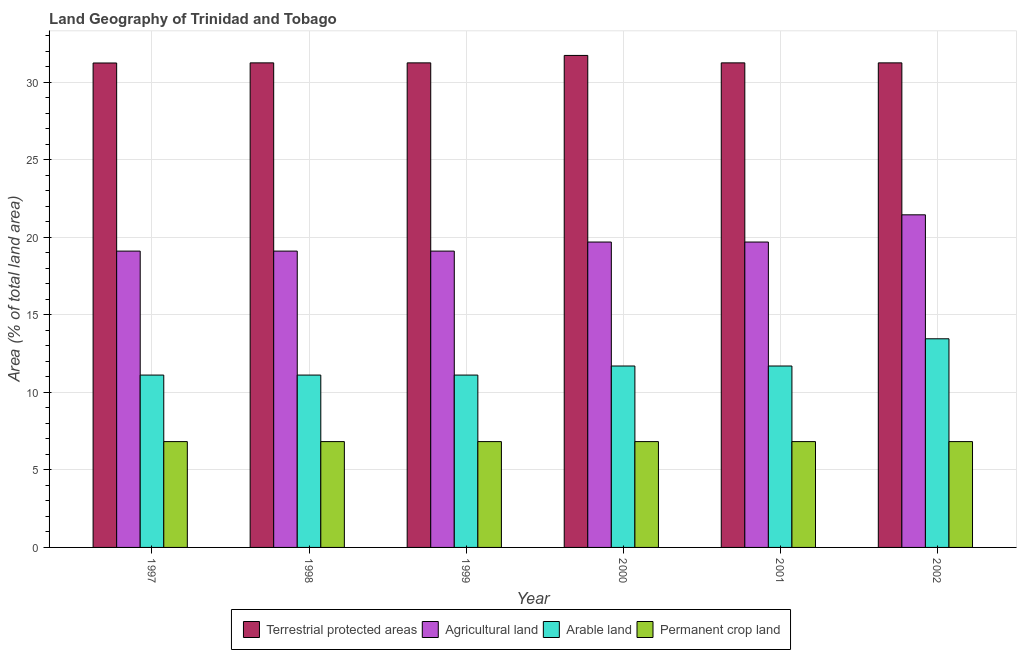How many different coloured bars are there?
Provide a succinct answer. 4. Are the number of bars per tick equal to the number of legend labels?
Your answer should be very brief. Yes. How many bars are there on the 3rd tick from the left?
Your answer should be very brief. 4. How many bars are there on the 5th tick from the right?
Your answer should be compact. 4. What is the percentage of area under permanent crop land in 1997?
Give a very brief answer. 6.82. Across all years, what is the maximum percentage of area under arable land?
Keep it short and to the point. 13.45. Across all years, what is the minimum percentage of area under agricultural land?
Provide a succinct answer. 19.1. In which year was the percentage of area under agricultural land maximum?
Offer a very short reply. 2002. In which year was the percentage of area under arable land minimum?
Give a very brief answer. 1997. What is the total percentage of area under agricultural land in the graph?
Give a very brief answer. 118.13. What is the difference between the percentage of area under arable land in 1998 and that in 2000?
Your answer should be compact. -0.58. What is the difference between the percentage of area under agricultural land in 1997 and the percentage of area under permanent crop land in 1998?
Make the answer very short. 0. What is the average percentage of area under agricultural land per year?
Provide a short and direct response. 19.69. In how many years, is the percentage of area under permanent crop land greater than 9 %?
Give a very brief answer. 0. What is the ratio of the percentage of land under terrestrial protection in 2000 to that in 2002?
Provide a succinct answer. 1.02. Is the percentage of area under permanent crop land in 1999 less than that in 2002?
Your answer should be compact. No. What is the difference between the highest and the second highest percentage of area under permanent crop land?
Provide a short and direct response. 0. What is the difference between the highest and the lowest percentage of land under terrestrial protection?
Give a very brief answer. 0.49. In how many years, is the percentage of area under arable land greater than the average percentage of area under arable land taken over all years?
Ensure brevity in your answer.  1. Is the sum of the percentage of area under permanent crop land in 1997 and 2000 greater than the maximum percentage of area under agricultural land across all years?
Your answer should be very brief. Yes. What does the 3rd bar from the left in 1999 represents?
Your answer should be very brief. Arable land. What does the 2nd bar from the right in 2000 represents?
Keep it short and to the point. Arable land. Is it the case that in every year, the sum of the percentage of land under terrestrial protection and percentage of area under agricultural land is greater than the percentage of area under arable land?
Give a very brief answer. Yes. How many years are there in the graph?
Your response must be concise. 6. What is the difference between two consecutive major ticks on the Y-axis?
Your response must be concise. 5. Are the values on the major ticks of Y-axis written in scientific E-notation?
Your answer should be compact. No. Does the graph contain any zero values?
Make the answer very short. No. Does the graph contain grids?
Your answer should be very brief. Yes. How many legend labels are there?
Give a very brief answer. 4. What is the title of the graph?
Provide a short and direct response. Land Geography of Trinidad and Tobago. What is the label or title of the Y-axis?
Your answer should be very brief. Area (% of total land area). What is the Area (% of total land area) in Terrestrial protected areas in 1997?
Offer a terse response. 31.23. What is the Area (% of total land area) of Agricultural land in 1997?
Ensure brevity in your answer.  19.1. What is the Area (% of total land area) of Arable land in 1997?
Provide a succinct answer. 11.11. What is the Area (% of total land area) of Permanent crop land in 1997?
Keep it short and to the point. 6.82. What is the Area (% of total land area) in Terrestrial protected areas in 1998?
Ensure brevity in your answer.  31.24. What is the Area (% of total land area) in Agricultural land in 1998?
Keep it short and to the point. 19.1. What is the Area (% of total land area) in Arable land in 1998?
Offer a terse response. 11.11. What is the Area (% of total land area) of Permanent crop land in 1998?
Your answer should be compact. 6.82. What is the Area (% of total land area) of Terrestrial protected areas in 1999?
Make the answer very short. 31.24. What is the Area (% of total land area) in Agricultural land in 1999?
Ensure brevity in your answer.  19.1. What is the Area (% of total land area) in Arable land in 1999?
Provide a succinct answer. 11.11. What is the Area (% of total land area) in Permanent crop land in 1999?
Your response must be concise. 6.82. What is the Area (% of total land area) in Terrestrial protected areas in 2000?
Provide a succinct answer. 31.72. What is the Area (% of total land area) of Agricultural land in 2000?
Offer a terse response. 19.69. What is the Area (% of total land area) in Arable land in 2000?
Your answer should be very brief. 11.7. What is the Area (% of total land area) of Permanent crop land in 2000?
Keep it short and to the point. 6.82. What is the Area (% of total land area) of Terrestrial protected areas in 2001?
Your answer should be compact. 31.24. What is the Area (% of total land area) in Agricultural land in 2001?
Your answer should be compact. 19.69. What is the Area (% of total land area) of Arable land in 2001?
Your answer should be very brief. 11.7. What is the Area (% of total land area) of Permanent crop land in 2001?
Offer a terse response. 6.82. What is the Area (% of total land area) in Terrestrial protected areas in 2002?
Your response must be concise. 31.24. What is the Area (% of total land area) in Agricultural land in 2002?
Offer a very short reply. 21.44. What is the Area (% of total land area) of Arable land in 2002?
Offer a very short reply. 13.45. What is the Area (% of total land area) of Permanent crop land in 2002?
Your answer should be compact. 6.82. Across all years, what is the maximum Area (% of total land area) of Terrestrial protected areas?
Keep it short and to the point. 31.72. Across all years, what is the maximum Area (% of total land area) of Agricultural land?
Provide a succinct answer. 21.44. Across all years, what is the maximum Area (% of total land area) of Arable land?
Provide a short and direct response. 13.45. Across all years, what is the maximum Area (% of total land area) of Permanent crop land?
Your response must be concise. 6.82. Across all years, what is the minimum Area (% of total land area) of Terrestrial protected areas?
Keep it short and to the point. 31.23. Across all years, what is the minimum Area (% of total land area) in Agricultural land?
Provide a short and direct response. 19.1. Across all years, what is the minimum Area (% of total land area) of Arable land?
Keep it short and to the point. 11.11. Across all years, what is the minimum Area (% of total land area) in Permanent crop land?
Keep it short and to the point. 6.82. What is the total Area (% of total land area) of Terrestrial protected areas in the graph?
Keep it short and to the point. 187.9. What is the total Area (% of total land area) of Agricultural land in the graph?
Keep it short and to the point. 118.13. What is the total Area (% of total land area) in Arable land in the graph?
Your answer should be very brief. 70.18. What is the total Area (% of total land area) of Permanent crop land in the graph?
Your answer should be very brief. 40.94. What is the difference between the Area (% of total land area) in Terrestrial protected areas in 1997 and that in 1998?
Keep it short and to the point. -0.01. What is the difference between the Area (% of total land area) in Terrestrial protected areas in 1997 and that in 1999?
Provide a short and direct response. -0.01. What is the difference between the Area (% of total land area) in Agricultural land in 1997 and that in 1999?
Provide a short and direct response. 0. What is the difference between the Area (% of total land area) of Arable land in 1997 and that in 1999?
Offer a terse response. 0. What is the difference between the Area (% of total land area) of Terrestrial protected areas in 1997 and that in 2000?
Provide a short and direct response. -0.49. What is the difference between the Area (% of total land area) in Agricultural land in 1997 and that in 2000?
Your answer should be very brief. -0.58. What is the difference between the Area (% of total land area) of Arable land in 1997 and that in 2000?
Give a very brief answer. -0.58. What is the difference between the Area (% of total land area) in Terrestrial protected areas in 1997 and that in 2001?
Provide a short and direct response. -0.01. What is the difference between the Area (% of total land area) in Agricultural land in 1997 and that in 2001?
Make the answer very short. -0.58. What is the difference between the Area (% of total land area) in Arable land in 1997 and that in 2001?
Offer a very short reply. -0.58. What is the difference between the Area (% of total land area) in Permanent crop land in 1997 and that in 2001?
Keep it short and to the point. 0. What is the difference between the Area (% of total land area) in Terrestrial protected areas in 1997 and that in 2002?
Ensure brevity in your answer.  -0.01. What is the difference between the Area (% of total land area) of Agricultural land in 1997 and that in 2002?
Make the answer very short. -2.34. What is the difference between the Area (% of total land area) in Arable land in 1997 and that in 2002?
Provide a short and direct response. -2.34. What is the difference between the Area (% of total land area) of Permanent crop land in 1997 and that in 2002?
Your answer should be very brief. 0. What is the difference between the Area (% of total land area) in Terrestrial protected areas in 1998 and that in 1999?
Provide a succinct answer. 0. What is the difference between the Area (% of total land area) in Arable land in 1998 and that in 1999?
Provide a succinct answer. 0. What is the difference between the Area (% of total land area) of Terrestrial protected areas in 1998 and that in 2000?
Your response must be concise. -0.48. What is the difference between the Area (% of total land area) in Agricultural land in 1998 and that in 2000?
Provide a short and direct response. -0.58. What is the difference between the Area (% of total land area) of Arable land in 1998 and that in 2000?
Your answer should be compact. -0.58. What is the difference between the Area (% of total land area) of Terrestrial protected areas in 1998 and that in 2001?
Provide a succinct answer. 0. What is the difference between the Area (% of total land area) in Agricultural land in 1998 and that in 2001?
Provide a succinct answer. -0.58. What is the difference between the Area (% of total land area) of Arable land in 1998 and that in 2001?
Provide a short and direct response. -0.58. What is the difference between the Area (% of total land area) in Permanent crop land in 1998 and that in 2001?
Provide a short and direct response. 0. What is the difference between the Area (% of total land area) of Terrestrial protected areas in 1998 and that in 2002?
Make the answer very short. 0. What is the difference between the Area (% of total land area) in Agricultural land in 1998 and that in 2002?
Keep it short and to the point. -2.34. What is the difference between the Area (% of total land area) in Arable land in 1998 and that in 2002?
Provide a short and direct response. -2.34. What is the difference between the Area (% of total land area) of Terrestrial protected areas in 1999 and that in 2000?
Your answer should be very brief. -0.48. What is the difference between the Area (% of total land area) of Agricultural land in 1999 and that in 2000?
Give a very brief answer. -0.58. What is the difference between the Area (% of total land area) in Arable land in 1999 and that in 2000?
Make the answer very short. -0.58. What is the difference between the Area (% of total land area) in Terrestrial protected areas in 1999 and that in 2001?
Your response must be concise. 0. What is the difference between the Area (% of total land area) in Agricultural land in 1999 and that in 2001?
Offer a very short reply. -0.58. What is the difference between the Area (% of total land area) of Arable land in 1999 and that in 2001?
Provide a succinct answer. -0.58. What is the difference between the Area (% of total land area) in Permanent crop land in 1999 and that in 2001?
Offer a very short reply. 0. What is the difference between the Area (% of total land area) of Terrestrial protected areas in 1999 and that in 2002?
Offer a terse response. 0. What is the difference between the Area (% of total land area) in Agricultural land in 1999 and that in 2002?
Keep it short and to the point. -2.34. What is the difference between the Area (% of total land area) in Arable land in 1999 and that in 2002?
Your response must be concise. -2.34. What is the difference between the Area (% of total land area) in Permanent crop land in 1999 and that in 2002?
Keep it short and to the point. 0. What is the difference between the Area (% of total land area) in Terrestrial protected areas in 2000 and that in 2001?
Provide a short and direct response. 0.48. What is the difference between the Area (% of total land area) in Agricultural land in 2000 and that in 2001?
Keep it short and to the point. 0. What is the difference between the Area (% of total land area) of Permanent crop land in 2000 and that in 2001?
Offer a very short reply. 0. What is the difference between the Area (% of total land area) of Terrestrial protected areas in 2000 and that in 2002?
Your answer should be very brief. 0.48. What is the difference between the Area (% of total land area) of Agricultural land in 2000 and that in 2002?
Give a very brief answer. -1.75. What is the difference between the Area (% of total land area) in Arable land in 2000 and that in 2002?
Give a very brief answer. -1.75. What is the difference between the Area (% of total land area) in Agricultural land in 2001 and that in 2002?
Provide a short and direct response. -1.75. What is the difference between the Area (% of total land area) in Arable land in 2001 and that in 2002?
Offer a terse response. -1.75. What is the difference between the Area (% of total land area) in Terrestrial protected areas in 1997 and the Area (% of total land area) in Agricultural land in 1998?
Your answer should be very brief. 12.13. What is the difference between the Area (% of total land area) in Terrestrial protected areas in 1997 and the Area (% of total land area) in Arable land in 1998?
Your answer should be compact. 20.12. What is the difference between the Area (% of total land area) in Terrestrial protected areas in 1997 and the Area (% of total land area) in Permanent crop land in 1998?
Your answer should be very brief. 24.41. What is the difference between the Area (% of total land area) of Agricultural land in 1997 and the Area (% of total land area) of Arable land in 1998?
Offer a terse response. 7.99. What is the difference between the Area (% of total land area) in Agricultural land in 1997 and the Area (% of total land area) in Permanent crop land in 1998?
Provide a succinct answer. 12.28. What is the difference between the Area (% of total land area) in Arable land in 1997 and the Area (% of total land area) in Permanent crop land in 1998?
Your answer should be very brief. 4.29. What is the difference between the Area (% of total land area) in Terrestrial protected areas in 1997 and the Area (% of total land area) in Agricultural land in 1999?
Keep it short and to the point. 12.13. What is the difference between the Area (% of total land area) in Terrestrial protected areas in 1997 and the Area (% of total land area) in Arable land in 1999?
Make the answer very short. 20.12. What is the difference between the Area (% of total land area) of Terrestrial protected areas in 1997 and the Area (% of total land area) of Permanent crop land in 1999?
Your answer should be very brief. 24.41. What is the difference between the Area (% of total land area) in Agricultural land in 1997 and the Area (% of total land area) in Arable land in 1999?
Offer a very short reply. 7.99. What is the difference between the Area (% of total land area) in Agricultural land in 1997 and the Area (% of total land area) in Permanent crop land in 1999?
Give a very brief answer. 12.28. What is the difference between the Area (% of total land area) of Arable land in 1997 and the Area (% of total land area) of Permanent crop land in 1999?
Your response must be concise. 4.29. What is the difference between the Area (% of total land area) in Terrestrial protected areas in 1997 and the Area (% of total land area) in Agricultural land in 2000?
Keep it short and to the point. 11.54. What is the difference between the Area (% of total land area) in Terrestrial protected areas in 1997 and the Area (% of total land area) in Arable land in 2000?
Offer a very short reply. 19.53. What is the difference between the Area (% of total land area) of Terrestrial protected areas in 1997 and the Area (% of total land area) of Permanent crop land in 2000?
Your answer should be very brief. 24.41. What is the difference between the Area (% of total land area) in Agricultural land in 1997 and the Area (% of total land area) in Arable land in 2000?
Make the answer very short. 7.41. What is the difference between the Area (% of total land area) in Agricultural land in 1997 and the Area (% of total land area) in Permanent crop land in 2000?
Ensure brevity in your answer.  12.28. What is the difference between the Area (% of total land area) in Arable land in 1997 and the Area (% of total land area) in Permanent crop land in 2000?
Offer a very short reply. 4.29. What is the difference between the Area (% of total land area) in Terrestrial protected areas in 1997 and the Area (% of total land area) in Agricultural land in 2001?
Provide a short and direct response. 11.54. What is the difference between the Area (% of total land area) in Terrestrial protected areas in 1997 and the Area (% of total land area) in Arable land in 2001?
Offer a very short reply. 19.53. What is the difference between the Area (% of total land area) in Terrestrial protected areas in 1997 and the Area (% of total land area) in Permanent crop land in 2001?
Provide a succinct answer. 24.41. What is the difference between the Area (% of total land area) in Agricultural land in 1997 and the Area (% of total land area) in Arable land in 2001?
Provide a short and direct response. 7.41. What is the difference between the Area (% of total land area) in Agricultural land in 1997 and the Area (% of total land area) in Permanent crop land in 2001?
Offer a terse response. 12.28. What is the difference between the Area (% of total land area) of Arable land in 1997 and the Area (% of total land area) of Permanent crop land in 2001?
Your answer should be compact. 4.29. What is the difference between the Area (% of total land area) of Terrestrial protected areas in 1997 and the Area (% of total land area) of Agricultural land in 2002?
Make the answer very short. 9.79. What is the difference between the Area (% of total land area) of Terrestrial protected areas in 1997 and the Area (% of total land area) of Arable land in 2002?
Provide a short and direct response. 17.78. What is the difference between the Area (% of total land area) in Terrestrial protected areas in 1997 and the Area (% of total land area) in Permanent crop land in 2002?
Your answer should be very brief. 24.41. What is the difference between the Area (% of total land area) in Agricultural land in 1997 and the Area (% of total land area) in Arable land in 2002?
Provide a succinct answer. 5.65. What is the difference between the Area (% of total land area) of Agricultural land in 1997 and the Area (% of total land area) of Permanent crop land in 2002?
Offer a terse response. 12.28. What is the difference between the Area (% of total land area) of Arable land in 1997 and the Area (% of total land area) of Permanent crop land in 2002?
Provide a succinct answer. 4.29. What is the difference between the Area (% of total land area) of Terrestrial protected areas in 1998 and the Area (% of total land area) of Agricultural land in 1999?
Your answer should be very brief. 12.13. What is the difference between the Area (% of total land area) in Terrestrial protected areas in 1998 and the Area (% of total land area) in Arable land in 1999?
Ensure brevity in your answer.  20.13. What is the difference between the Area (% of total land area) in Terrestrial protected areas in 1998 and the Area (% of total land area) in Permanent crop land in 1999?
Your answer should be compact. 24.42. What is the difference between the Area (% of total land area) in Agricultural land in 1998 and the Area (% of total land area) in Arable land in 1999?
Keep it short and to the point. 7.99. What is the difference between the Area (% of total land area) in Agricultural land in 1998 and the Area (% of total land area) in Permanent crop land in 1999?
Your answer should be very brief. 12.28. What is the difference between the Area (% of total land area) in Arable land in 1998 and the Area (% of total land area) in Permanent crop land in 1999?
Provide a succinct answer. 4.29. What is the difference between the Area (% of total land area) of Terrestrial protected areas in 1998 and the Area (% of total land area) of Agricultural land in 2000?
Your response must be concise. 11.55. What is the difference between the Area (% of total land area) of Terrestrial protected areas in 1998 and the Area (% of total land area) of Arable land in 2000?
Provide a short and direct response. 19.54. What is the difference between the Area (% of total land area) of Terrestrial protected areas in 1998 and the Area (% of total land area) of Permanent crop land in 2000?
Make the answer very short. 24.42. What is the difference between the Area (% of total land area) in Agricultural land in 1998 and the Area (% of total land area) in Arable land in 2000?
Offer a very short reply. 7.41. What is the difference between the Area (% of total land area) in Agricultural land in 1998 and the Area (% of total land area) in Permanent crop land in 2000?
Offer a very short reply. 12.28. What is the difference between the Area (% of total land area) in Arable land in 1998 and the Area (% of total land area) in Permanent crop land in 2000?
Offer a very short reply. 4.29. What is the difference between the Area (% of total land area) of Terrestrial protected areas in 1998 and the Area (% of total land area) of Agricultural land in 2001?
Provide a short and direct response. 11.55. What is the difference between the Area (% of total land area) of Terrestrial protected areas in 1998 and the Area (% of total land area) of Arable land in 2001?
Provide a succinct answer. 19.54. What is the difference between the Area (% of total land area) of Terrestrial protected areas in 1998 and the Area (% of total land area) of Permanent crop land in 2001?
Your answer should be very brief. 24.42. What is the difference between the Area (% of total land area) in Agricultural land in 1998 and the Area (% of total land area) in Arable land in 2001?
Your answer should be compact. 7.41. What is the difference between the Area (% of total land area) in Agricultural land in 1998 and the Area (% of total land area) in Permanent crop land in 2001?
Give a very brief answer. 12.28. What is the difference between the Area (% of total land area) of Arable land in 1998 and the Area (% of total land area) of Permanent crop land in 2001?
Offer a terse response. 4.29. What is the difference between the Area (% of total land area) in Terrestrial protected areas in 1998 and the Area (% of total land area) in Agricultural land in 2002?
Provide a short and direct response. 9.8. What is the difference between the Area (% of total land area) of Terrestrial protected areas in 1998 and the Area (% of total land area) of Arable land in 2002?
Your answer should be compact. 17.79. What is the difference between the Area (% of total land area) in Terrestrial protected areas in 1998 and the Area (% of total land area) in Permanent crop land in 2002?
Offer a very short reply. 24.42. What is the difference between the Area (% of total land area) of Agricultural land in 1998 and the Area (% of total land area) of Arable land in 2002?
Your answer should be very brief. 5.65. What is the difference between the Area (% of total land area) in Agricultural land in 1998 and the Area (% of total land area) in Permanent crop land in 2002?
Make the answer very short. 12.28. What is the difference between the Area (% of total land area) of Arable land in 1998 and the Area (% of total land area) of Permanent crop land in 2002?
Provide a short and direct response. 4.29. What is the difference between the Area (% of total land area) of Terrestrial protected areas in 1999 and the Area (% of total land area) of Agricultural land in 2000?
Make the answer very short. 11.55. What is the difference between the Area (% of total land area) in Terrestrial protected areas in 1999 and the Area (% of total land area) in Arable land in 2000?
Offer a very short reply. 19.54. What is the difference between the Area (% of total land area) in Terrestrial protected areas in 1999 and the Area (% of total land area) in Permanent crop land in 2000?
Your answer should be very brief. 24.42. What is the difference between the Area (% of total land area) in Agricultural land in 1999 and the Area (% of total land area) in Arable land in 2000?
Ensure brevity in your answer.  7.41. What is the difference between the Area (% of total land area) in Agricultural land in 1999 and the Area (% of total land area) in Permanent crop land in 2000?
Make the answer very short. 12.28. What is the difference between the Area (% of total land area) in Arable land in 1999 and the Area (% of total land area) in Permanent crop land in 2000?
Your answer should be very brief. 4.29. What is the difference between the Area (% of total land area) in Terrestrial protected areas in 1999 and the Area (% of total land area) in Agricultural land in 2001?
Keep it short and to the point. 11.55. What is the difference between the Area (% of total land area) of Terrestrial protected areas in 1999 and the Area (% of total land area) of Arable land in 2001?
Your answer should be very brief. 19.54. What is the difference between the Area (% of total land area) in Terrestrial protected areas in 1999 and the Area (% of total land area) in Permanent crop land in 2001?
Your answer should be compact. 24.42. What is the difference between the Area (% of total land area) of Agricultural land in 1999 and the Area (% of total land area) of Arable land in 2001?
Ensure brevity in your answer.  7.41. What is the difference between the Area (% of total land area) in Agricultural land in 1999 and the Area (% of total land area) in Permanent crop land in 2001?
Provide a succinct answer. 12.28. What is the difference between the Area (% of total land area) in Arable land in 1999 and the Area (% of total land area) in Permanent crop land in 2001?
Your answer should be very brief. 4.29. What is the difference between the Area (% of total land area) in Terrestrial protected areas in 1999 and the Area (% of total land area) in Agricultural land in 2002?
Keep it short and to the point. 9.8. What is the difference between the Area (% of total land area) in Terrestrial protected areas in 1999 and the Area (% of total land area) in Arable land in 2002?
Provide a short and direct response. 17.79. What is the difference between the Area (% of total land area) of Terrestrial protected areas in 1999 and the Area (% of total land area) of Permanent crop land in 2002?
Offer a very short reply. 24.42. What is the difference between the Area (% of total land area) in Agricultural land in 1999 and the Area (% of total land area) in Arable land in 2002?
Your answer should be very brief. 5.65. What is the difference between the Area (% of total land area) in Agricultural land in 1999 and the Area (% of total land area) in Permanent crop land in 2002?
Your answer should be very brief. 12.28. What is the difference between the Area (% of total land area) of Arable land in 1999 and the Area (% of total land area) of Permanent crop land in 2002?
Give a very brief answer. 4.29. What is the difference between the Area (% of total land area) in Terrestrial protected areas in 2000 and the Area (% of total land area) in Agricultural land in 2001?
Your answer should be compact. 12.03. What is the difference between the Area (% of total land area) in Terrestrial protected areas in 2000 and the Area (% of total land area) in Arable land in 2001?
Ensure brevity in your answer.  20.02. What is the difference between the Area (% of total land area) in Terrestrial protected areas in 2000 and the Area (% of total land area) in Permanent crop land in 2001?
Make the answer very short. 24.9. What is the difference between the Area (% of total land area) in Agricultural land in 2000 and the Area (% of total land area) in Arable land in 2001?
Your answer should be very brief. 7.99. What is the difference between the Area (% of total land area) of Agricultural land in 2000 and the Area (% of total land area) of Permanent crop land in 2001?
Your answer should be compact. 12.87. What is the difference between the Area (% of total land area) of Arable land in 2000 and the Area (% of total land area) of Permanent crop land in 2001?
Ensure brevity in your answer.  4.87. What is the difference between the Area (% of total land area) in Terrestrial protected areas in 2000 and the Area (% of total land area) in Agricultural land in 2002?
Provide a succinct answer. 10.28. What is the difference between the Area (% of total land area) of Terrestrial protected areas in 2000 and the Area (% of total land area) of Arable land in 2002?
Keep it short and to the point. 18.27. What is the difference between the Area (% of total land area) of Terrestrial protected areas in 2000 and the Area (% of total land area) of Permanent crop land in 2002?
Give a very brief answer. 24.9. What is the difference between the Area (% of total land area) of Agricultural land in 2000 and the Area (% of total land area) of Arable land in 2002?
Make the answer very short. 6.24. What is the difference between the Area (% of total land area) in Agricultural land in 2000 and the Area (% of total land area) in Permanent crop land in 2002?
Offer a terse response. 12.87. What is the difference between the Area (% of total land area) in Arable land in 2000 and the Area (% of total land area) in Permanent crop land in 2002?
Offer a very short reply. 4.87. What is the difference between the Area (% of total land area) in Terrestrial protected areas in 2001 and the Area (% of total land area) in Agricultural land in 2002?
Your answer should be very brief. 9.8. What is the difference between the Area (% of total land area) in Terrestrial protected areas in 2001 and the Area (% of total land area) in Arable land in 2002?
Make the answer very short. 17.79. What is the difference between the Area (% of total land area) in Terrestrial protected areas in 2001 and the Area (% of total land area) in Permanent crop land in 2002?
Your answer should be compact. 24.42. What is the difference between the Area (% of total land area) in Agricultural land in 2001 and the Area (% of total land area) in Arable land in 2002?
Provide a short and direct response. 6.24. What is the difference between the Area (% of total land area) in Agricultural land in 2001 and the Area (% of total land area) in Permanent crop land in 2002?
Offer a very short reply. 12.87. What is the difference between the Area (% of total land area) of Arable land in 2001 and the Area (% of total land area) of Permanent crop land in 2002?
Ensure brevity in your answer.  4.87. What is the average Area (% of total land area) in Terrestrial protected areas per year?
Ensure brevity in your answer.  31.32. What is the average Area (% of total land area) in Agricultural land per year?
Your answer should be compact. 19.69. What is the average Area (% of total land area) in Arable land per year?
Keep it short and to the point. 11.7. What is the average Area (% of total land area) in Permanent crop land per year?
Provide a short and direct response. 6.82. In the year 1997, what is the difference between the Area (% of total land area) of Terrestrial protected areas and Area (% of total land area) of Agricultural land?
Give a very brief answer. 12.13. In the year 1997, what is the difference between the Area (% of total land area) in Terrestrial protected areas and Area (% of total land area) in Arable land?
Keep it short and to the point. 20.12. In the year 1997, what is the difference between the Area (% of total land area) in Terrestrial protected areas and Area (% of total land area) in Permanent crop land?
Your answer should be very brief. 24.41. In the year 1997, what is the difference between the Area (% of total land area) in Agricultural land and Area (% of total land area) in Arable land?
Provide a short and direct response. 7.99. In the year 1997, what is the difference between the Area (% of total land area) in Agricultural land and Area (% of total land area) in Permanent crop land?
Offer a terse response. 12.28. In the year 1997, what is the difference between the Area (% of total land area) of Arable land and Area (% of total land area) of Permanent crop land?
Your response must be concise. 4.29. In the year 1998, what is the difference between the Area (% of total land area) in Terrestrial protected areas and Area (% of total land area) in Agricultural land?
Ensure brevity in your answer.  12.13. In the year 1998, what is the difference between the Area (% of total land area) of Terrestrial protected areas and Area (% of total land area) of Arable land?
Provide a succinct answer. 20.13. In the year 1998, what is the difference between the Area (% of total land area) in Terrestrial protected areas and Area (% of total land area) in Permanent crop land?
Ensure brevity in your answer.  24.42. In the year 1998, what is the difference between the Area (% of total land area) of Agricultural land and Area (% of total land area) of Arable land?
Make the answer very short. 7.99. In the year 1998, what is the difference between the Area (% of total land area) in Agricultural land and Area (% of total land area) in Permanent crop land?
Ensure brevity in your answer.  12.28. In the year 1998, what is the difference between the Area (% of total land area) in Arable land and Area (% of total land area) in Permanent crop land?
Your answer should be very brief. 4.29. In the year 1999, what is the difference between the Area (% of total land area) of Terrestrial protected areas and Area (% of total land area) of Agricultural land?
Your answer should be very brief. 12.13. In the year 1999, what is the difference between the Area (% of total land area) in Terrestrial protected areas and Area (% of total land area) in Arable land?
Your answer should be very brief. 20.13. In the year 1999, what is the difference between the Area (% of total land area) of Terrestrial protected areas and Area (% of total land area) of Permanent crop land?
Offer a very short reply. 24.42. In the year 1999, what is the difference between the Area (% of total land area) in Agricultural land and Area (% of total land area) in Arable land?
Give a very brief answer. 7.99. In the year 1999, what is the difference between the Area (% of total land area) of Agricultural land and Area (% of total land area) of Permanent crop land?
Your answer should be compact. 12.28. In the year 1999, what is the difference between the Area (% of total land area) of Arable land and Area (% of total land area) of Permanent crop land?
Offer a very short reply. 4.29. In the year 2000, what is the difference between the Area (% of total land area) in Terrestrial protected areas and Area (% of total land area) in Agricultural land?
Give a very brief answer. 12.03. In the year 2000, what is the difference between the Area (% of total land area) in Terrestrial protected areas and Area (% of total land area) in Arable land?
Give a very brief answer. 20.02. In the year 2000, what is the difference between the Area (% of total land area) in Terrestrial protected areas and Area (% of total land area) in Permanent crop land?
Your response must be concise. 24.9. In the year 2000, what is the difference between the Area (% of total land area) of Agricultural land and Area (% of total land area) of Arable land?
Offer a very short reply. 7.99. In the year 2000, what is the difference between the Area (% of total land area) of Agricultural land and Area (% of total land area) of Permanent crop land?
Your answer should be compact. 12.87. In the year 2000, what is the difference between the Area (% of total land area) in Arable land and Area (% of total land area) in Permanent crop land?
Give a very brief answer. 4.87. In the year 2001, what is the difference between the Area (% of total land area) of Terrestrial protected areas and Area (% of total land area) of Agricultural land?
Your answer should be compact. 11.55. In the year 2001, what is the difference between the Area (% of total land area) of Terrestrial protected areas and Area (% of total land area) of Arable land?
Your answer should be compact. 19.54. In the year 2001, what is the difference between the Area (% of total land area) of Terrestrial protected areas and Area (% of total land area) of Permanent crop land?
Your answer should be compact. 24.42. In the year 2001, what is the difference between the Area (% of total land area) in Agricultural land and Area (% of total land area) in Arable land?
Your answer should be compact. 7.99. In the year 2001, what is the difference between the Area (% of total land area) of Agricultural land and Area (% of total land area) of Permanent crop land?
Your response must be concise. 12.87. In the year 2001, what is the difference between the Area (% of total land area) in Arable land and Area (% of total land area) in Permanent crop land?
Ensure brevity in your answer.  4.87. In the year 2002, what is the difference between the Area (% of total land area) in Terrestrial protected areas and Area (% of total land area) in Agricultural land?
Your response must be concise. 9.8. In the year 2002, what is the difference between the Area (% of total land area) in Terrestrial protected areas and Area (% of total land area) in Arable land?
Your answer should be very brief. 17.79. In the year 2002, what is the difference between the Area (% of total land area) in Terrestrial protected areas and Area (% of total land area) in Permanent crop land?
Make the answer very short. 24.42. In the year 2002, what is the difference between the Area (% of total land area) in Agricultural land and Area (% of total land area) in Arable land?
Your answer should be very brief. 7.99. In the year 2002, what is the difference between the Area (% of total land area) of Agricultural land and Area (% of total land area) of Permanent crop land?
Provide a short and direct response. 14.62. In the year 2002, what is the difference between the Area (% of total land area) of Arable land and Area (% of total land area) of Permanent crop land?
Keep it short and to the point. 6.63. What is the ratio of the Area (% of total land area) in Terrestrial protected areas in 1997 to that in 1998?
Your answer should be compact. 1. What is the ratio of the Area (% of total land area) in Agricultural land in 1997 to that in 1998?
Ensure brevity in your answer.  1. What is the ratio of the Area (% of total land area) in Agricultural land in 1997 to that in 1999?
Ensure brevity in your answer.  1. What is the ratio of the Area (% of total land area) of Arable land in 1997 to that in 1999?
Give a very brief answer. 1. What is the ratio of the Area (% of total land area) of Terrestrial protected areas in 1997 to that in 2000?
Provide a succinct answer. 0.98. What is the ratio of the Area (% of total land area) in Agricultural land in 1997 to that in 2000?
Provide a short and direct response. 0.97. What is the ratio of the Area (% of total land area) in Permanent crop land in 1997 to that in 2000?
Make the answer very short. 1. What is the ratio of the Area (% of total land area) in Agricultural land in 1997 to that in 2001?
Your response must be concise. 0.97. What is the ratio of the Area (% of total land area) of Permanent crop land in 1997 to that in 2001?
Keep it short and to the point. 1. What is the ratio of the Area (% of total land area) of Terrestrial protected areas in 1997 to that in 2002?
Offer a terse response. 1. What is the ratio of the Area (% of total land area) in Agricultural land in 1997 to that in 2002?
Provide a short and direct response. 0.89. What is the ratio of the Area (% of total land area) of Arable land in 1997 to that in 2002?
Your answer should be compact. 0.83. What is the ratio of the Area (% of total land area) in Permanent crop land in 1997 to that in 2002?
Offer a terse response. 1. What is the ratio of the Area (% of total land area) of Arable land in 1998 to that in 1999?
Provide a short and direct response. 1. What is the ratio of the Area (% of total land area) in Terrestrial protected areas in 1998 to that in 2000?
Your response must be concise. 0.98. What is the ratio of the Area (% of total land area) in Agricultural land in 1998 to that in 2000?
Your response must be concise. 0.97. What is the ratio of the Area (% of total land area) in Arable land in 1998 to that in 2000?
Give a very brief answer. 0.95. What is the ratio of the Area (% of total land area) of Permanent crop land in 1998 to that in 2000?
Ensure brevity in your answer.  1. What is the ratio of the Area (% of total land area) of Agricultural land in 1998 to that in 2001?
Offer a terse response. 0.97. What is the ratio of the Area (% of total land area) in Agricultural land in 1998 to that in 2002?
Keep it short and to the point. 0.89. What is the ratio of the Area (% of total land area) of Arable land in 1998 to that in 2002?
Give a very brief answer. 0.83. What is the ratio of the Area (% of total land area) in Permanent crop land in 1998 to that in 2002?
Offer a terse response. 1. What is the ratio of the Area (% of total land area) in Terrestrial protected areas in 1999 to that in 2000?
Make the answer very short. 0.98. What is the ratio of the Area (% of total land area) of Agricultural land in 1999 to that in 2000?
Make the answer very short. 0.97. What is the ratio of the Area (% of total land area) of Arable land in 1999 to that in 2000?
Offer a terse response. 0.95. What is the ratio of the Area (% of total land area) in Terrestrial protected areas in 1999 to that in 2001?
Your answer should be compact. 1. What is the ratio of the Area (% of total land area) of Agricultural land in 1999 to that in 2001?
Your response must be concise. 0.97. What is the ratio of the Area (% of total land area) in Arable land in 1999 to that in 2001?
Offer a terse response. 0.95. What is the ratio of the Area (% of total land area) in Permanent crop land in 1999 to that in 2001?
Offer a terse response. 1. What is the ratio of the Area (% of total land area) in Terrestrial protected areas in 1999 to that in 2002?
Make the answer very short. 1. What is the ratio of the Area (% of total land area) of Agricultural land in 1999 to that in 2002?
Offer a very short reply. 0.89. What is the ratio of the Area (% of total land area) in Arable land in 1999 to that in 2002?
Provide a short and direct response. 0.83. What is the ratio of the Area (% of total land area) in Terrestrial protected areas in 2000 to that in 2001?
Provide a succinct answer. 1.02. What is the ratio of the Area (% of total land area) in Terrestrial protected areas in 2000 to that in 2002?
Offer a terse response. 1.02. What is the ratio of the Area (% of total land area) in Agricultural land in 2000 to that in 2002?
Provide a short and direct response. 0.92. What is the ratio of the Area (% of total land area) in Arable land in 2000 to that in 2002?
Your answer should be very brief. 0.87. What is the ratio of the Area (% of total land area) of Terrestrial protected areas in 2001 to that in 2002?
Your answer should be very brief. 1. What is the ratio of the Area (% of total land area) of Agricultural land in 2001 to that in 2002?
Provide a short and direct response. 0.92. What is the ratio of the Area (% of total land area) of Arable land in 2001 to that in 2002?
Keep it short and to the point. 0.87. What is the ratio of the Area (% of total land area) of Permanent crop land in 2001 to that in 2002?
Offer a terse response. 1. What is the difference between the highest and the second highest Area (% of total land area) in Terrestrial protected areas?
Ensure brevity in your answer.  0.48. What is the difference between the highest and the second highest Area (% of total land area) in Agricultural land?
Your response must be concise. 1.75. What is the difference between the highest and the second highest Area (% of total land area) of Arable land?
Your answer should be compact. 1.75. What is the difference between the highest and the lowest Area (% of total land area) in Terrestrial protected areas?
Give a very brief answer. 0.49. What is the difference between the highest and the lowest Area (% of total land area) in Agricultural land?
Your answer should be compact. 2.34. What is the difference between the highest and the lowest Area (% of total land area) in Arable land?
Offer a very short reply. 2.34. What is the difference between the highest and the lowest Area (% of total land area) of Permanent crop land?
Your response must be concise. 0. 